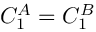<formula> <loc_0><loc_0><loc_500><loc_500>C _ { 1 } ^ { A } = C _ { 1 } ^ { B }</formula> 